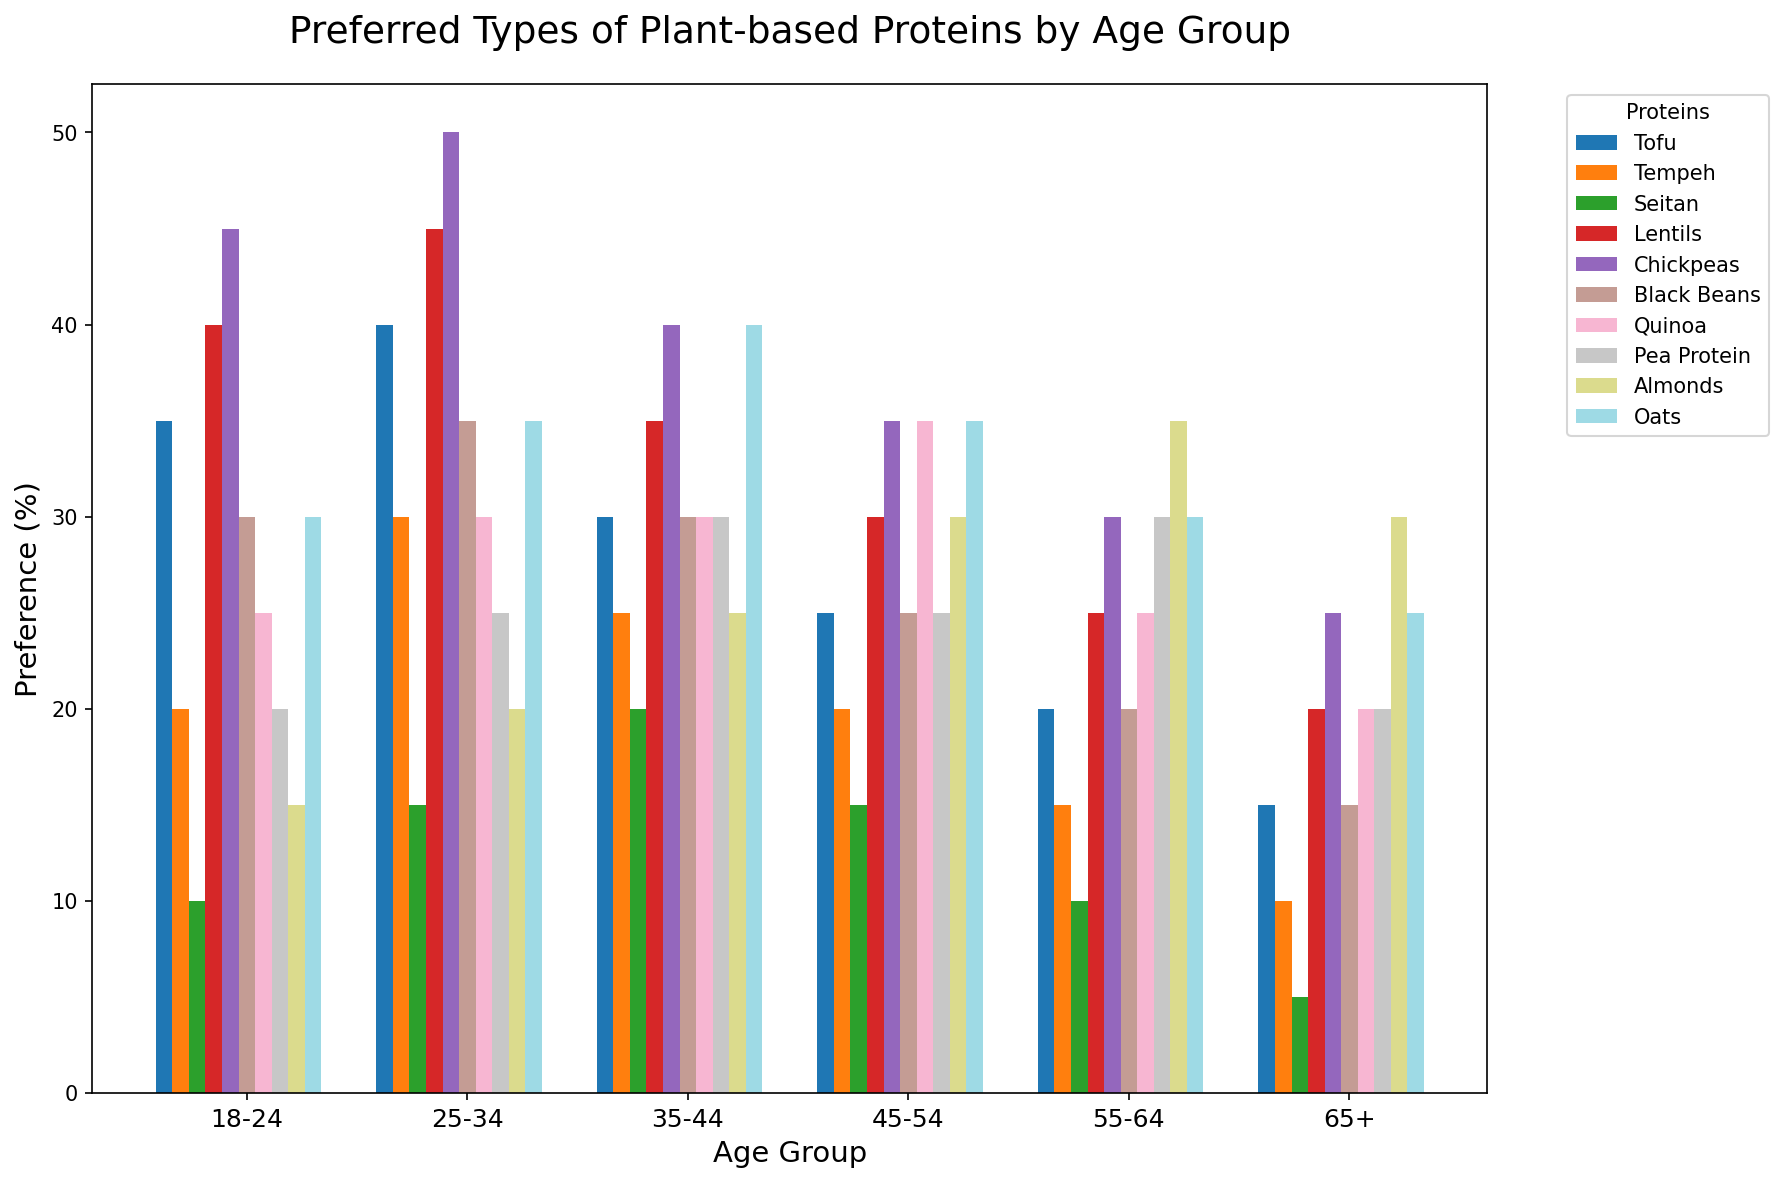What age group has the highest preference for Chickpeas? By observing the height of the bars representing Chickpeas (dark green) for each age group, we can see that the 25-34 age group has the tallest bar.
Answer: 25-34 Which age group shows the lowest preference for Tofu? By comparing the heights of the bars representing Tofu (light blue) across different age groups, the 65+ age group has the shortest bar.
Answer: 65+ Is the preference for Quinoa higher or lower in the 45-54 age group compared to the 35-44 age group? The height of the Quinoa (light purple) bar for the 45-54 age group is taller compared to the height of the same bar for the 35-44 age group.
Answer: Higher What is the sum of preferences for Lentils and Black Beans in the 18-24 age group? By summing the values for Lentils (40) and Black Beans (30) for the 18-24 age group, we get 40 + 30.
Answer: 70 Which age group prefers Almonds the most and by how much percentage? The height of the bars representing Almonds (orange) shows that the 55-64 age group has the highest preference, with a height of 35%.
Answer: 55-64, 35% Compare the preference for Pea Protein and Tempeh in the 25-34 age group. Which one is preferred more? By comparing the heights of the bars for Pea Protein (navy blue) and Tempeh (dark blue) in the 25-34 age group, Pea Protein is higher.
Answer: Pea Protein Across all age groups, which plant-based protein shows a steady increase or decrease in preference? When we follow the height trends of each bar for each age group, Tofu (light blue) shows a decreasing trend as the age group increases.
Answer: Tofu (decrease) What is the average preference for Oats across all age groups? The preferences for Oats are 30, 35, 40, 35, 30, and 25. Summing these up gives 195. Dividing by the number of age groups (6), the average is 195/6.
Answer: 32.5 Which age group has equal preference for Black Beans and Pea Protein, and what is the percentage? For the age group 45-54, the height of the bars for Black Beans (turquoise) and Pea Protein (navy blue) are both 25%.
Answer: 45-54, 25% Which two proteins do the 18-24 age group prefer the most and least respectively? By comparing the heights of all the bars for the 18-24 age group, we observe that Chickpeas (45%, highest) and Seitan (10%, lowest) are the most and least preferred respectively.
Answer: Chickpeas, Seitan 